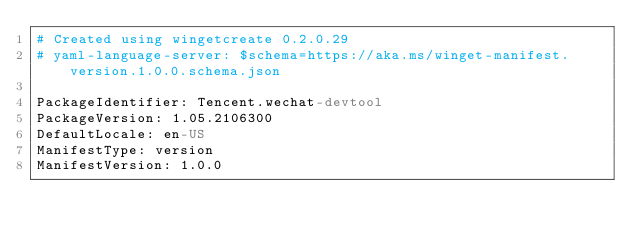Convert code to text. <code><loc_0><loc_0><loc_500><loc_500><_YAML_># Created using wingetcreate 0.2.0.29
# yaml-language-server: $schema=https://aka.ms/winget-manifest.version.1.0.0.schema.json

PackageIdentifier: Tencent.wechat-devtool
PackageVersion: 1.05.2106300
DefaultLocale: en-US
ManifestType: version
ManifestVersion: 1.0.0

</code> 